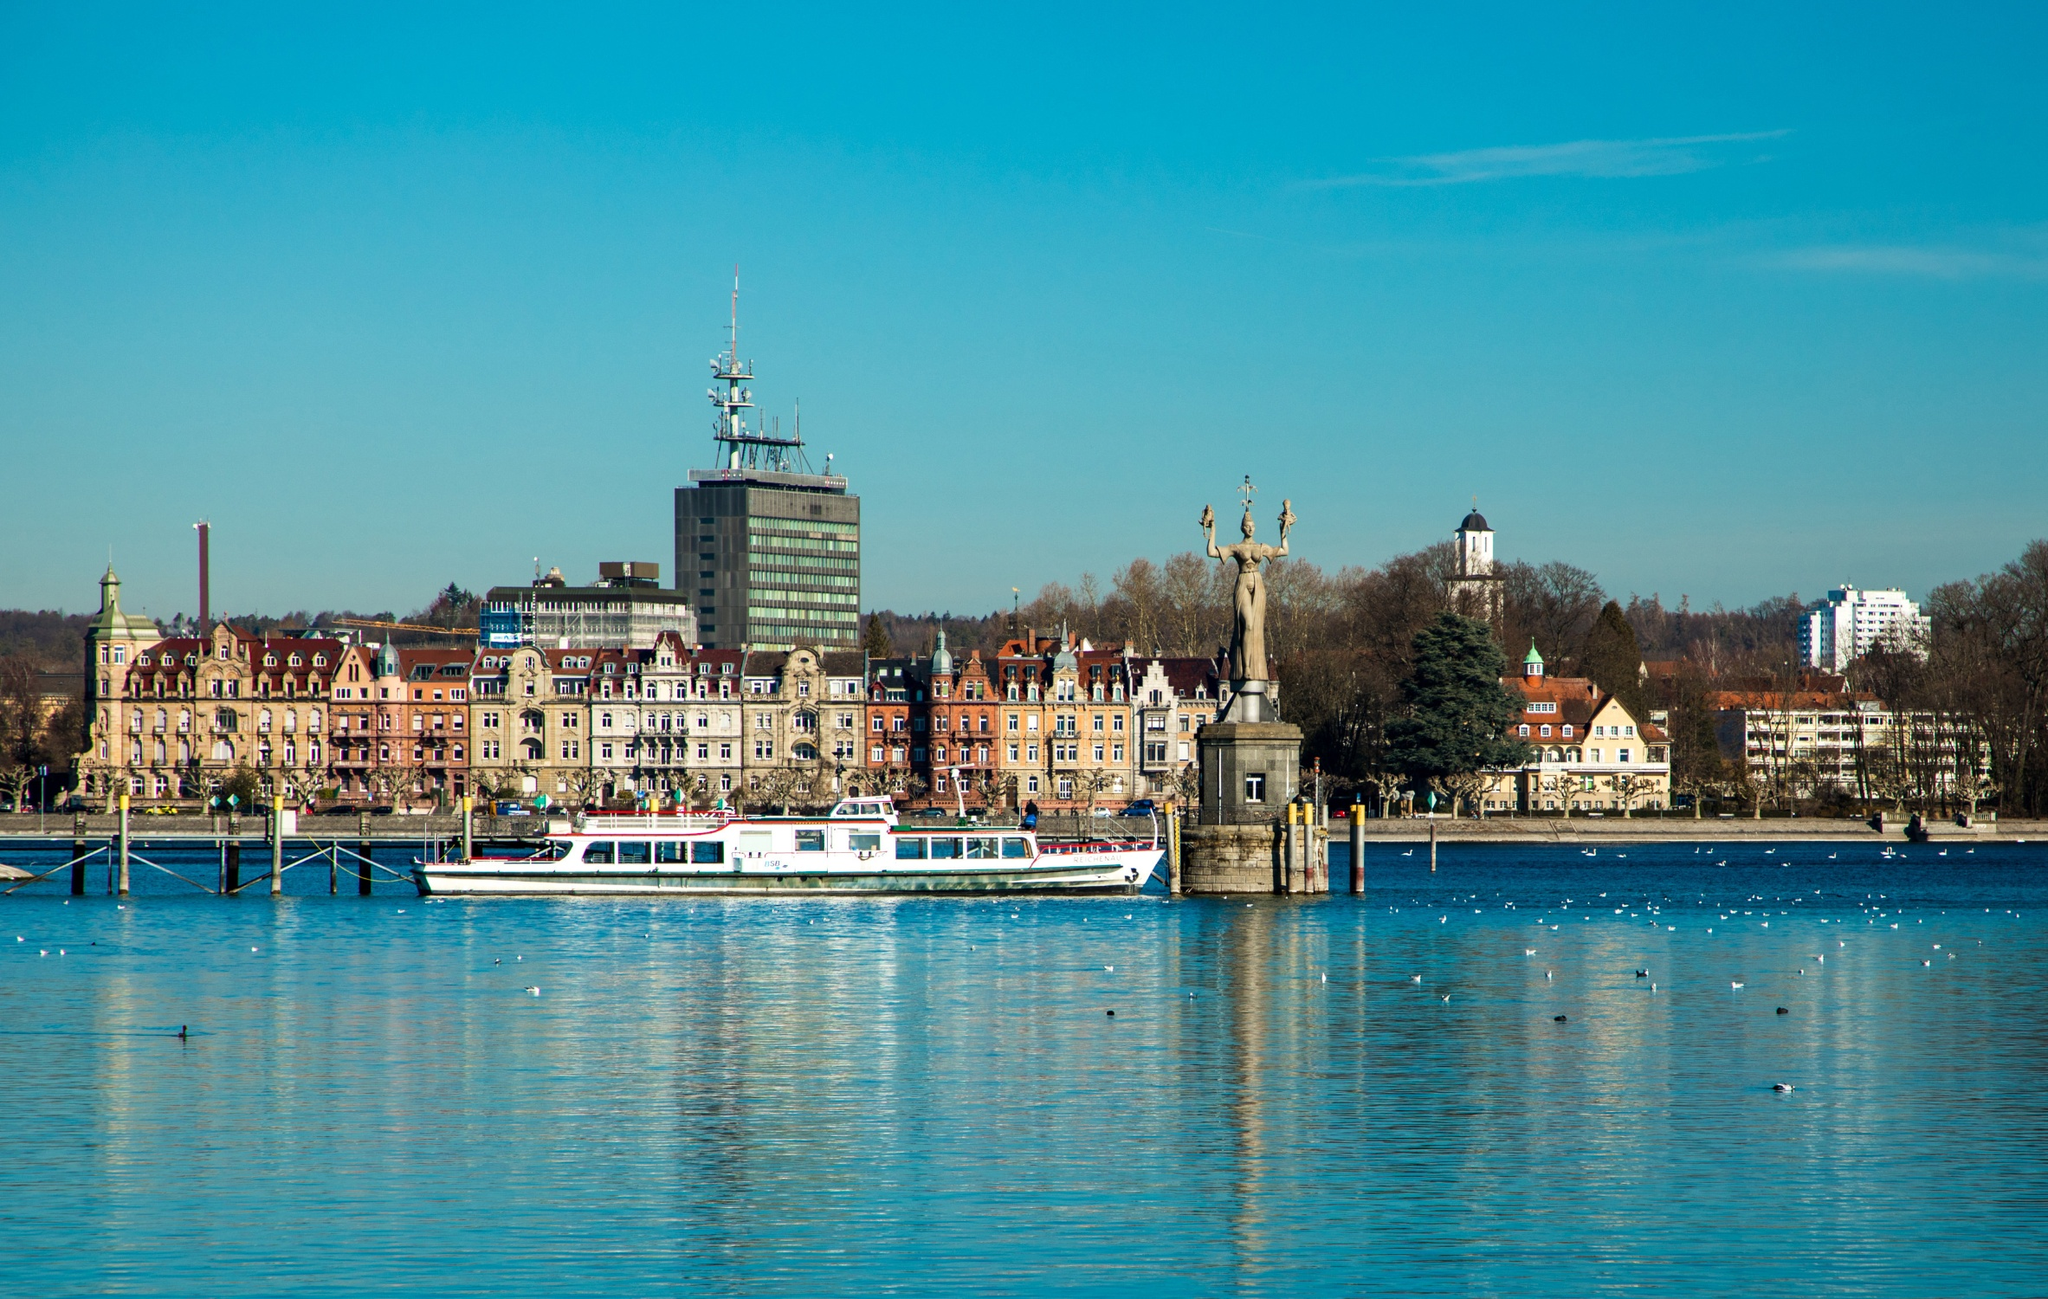If the image were part of a movie scene, what would be happening at this moment? In a movie scene set in Constance Harbour, the image captures a pivotal moment where the protagonist, Maria, embarks on a crucial mission. As she boards the white boat, her mind races with memories of her past and uncertainties about the future. In the background, the historical statue stands as a silent witness to the unfolding drama. Maria clutches a mysterious letter that promises to uncover long-hidden secrets of her family and the town's history. The boat sets off across the tranquil waters, the serene environment juxtaposing Maria’s inner turmoil and determination. The harbor buzzes subtly with life, providing a dynamic backdrop as the camera pans out, setting the stage for an adventure filled with suspense, discovery, and profound personal revelations.  Are there any particular events or festivals held in Constance Harbour? Yes, Constance Harbour is renowned for hosting several vibrant events and festivals throughout the year. One of the most notable is the 'Seenachtsfest', a spectacular summer festival featuring live music, cultural performances, and a grand fireworks display that lights up the sky above the harbour. Another key event is the 'Christmas Market by the Lake', where the festive spirit comes alive with illuminated stalls, seasonal treats, and a merry atmosphere. During these times, the harbour transforms into a bustling hub of celebration, drawing locals and visitors alike to join in the festivities and enjoy the unique charm of Constance. 